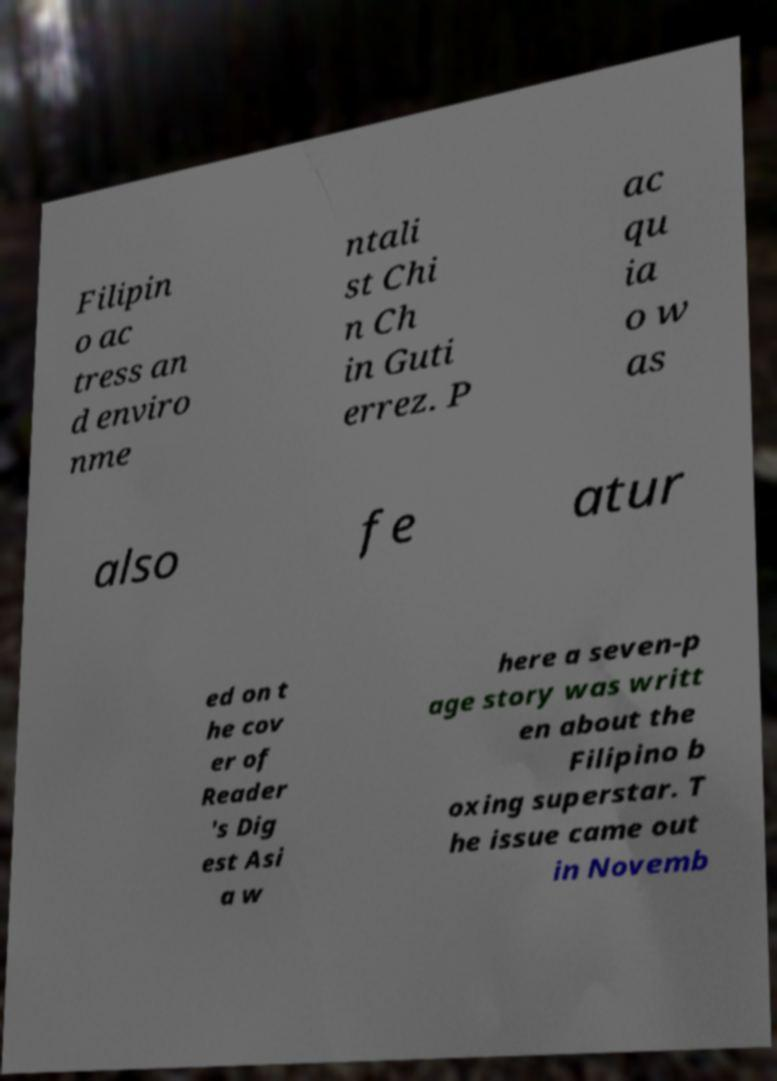For documentation purposes, I need the text within this image transcribed. Could you provide that? Filipin o ac tress an d enviro nme ntali st Chi n Ch in Guti errez. P ac qu ia o w as also fe atur ed on t he cov er of Reader 's Dig est Asi a w here a seven-p age story was writt en about the Filipino b oxing superstar. T he issue came out in Novemb 